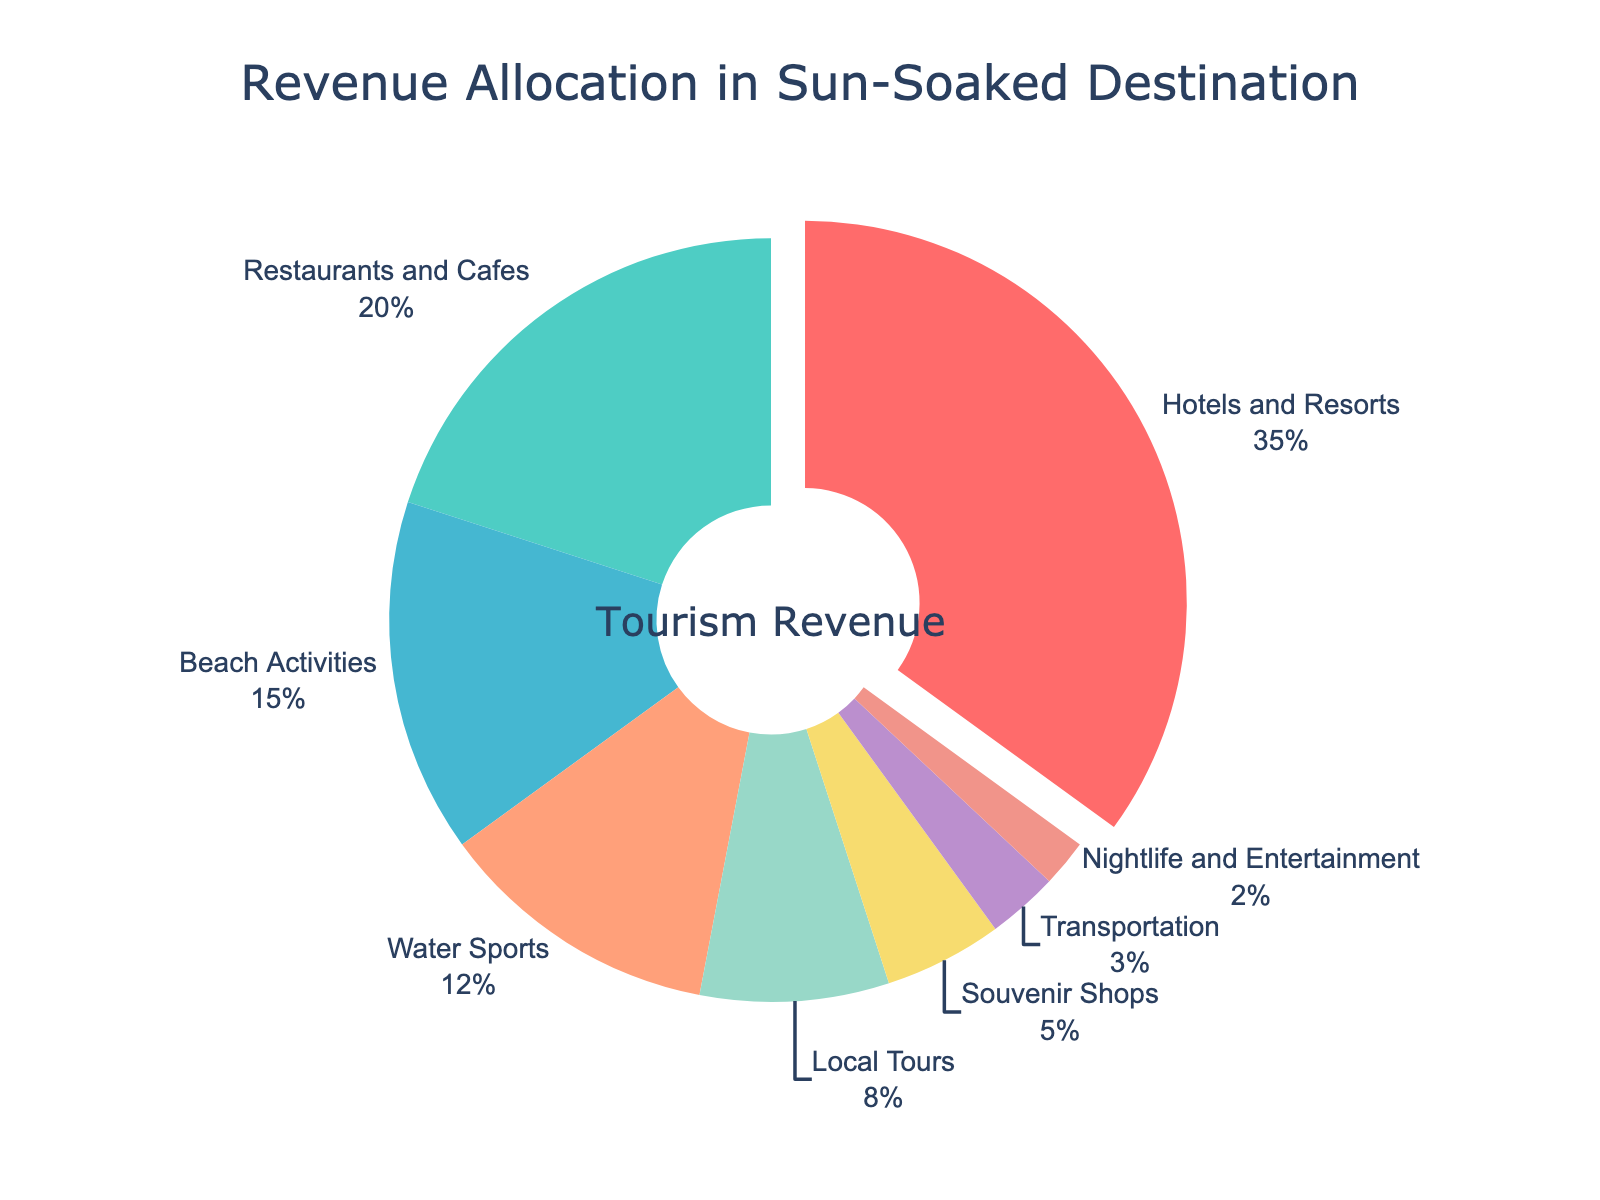What is the title of the plot? The title of the plot is located at the top center of the figure. It reads "Revenue Allocation in Sun-Soaked Destination"
Answer: Revenue Allocation in Sun-Soaked Destination What sector receives the highest revenue percentage? By observing the pie chart, the largest segment corresponds to one of the labels. Here, the largest segment is assigned to "Hotels and Resorts" with 35%.
Answer: Hotels and Resorts What percent of revenue is allocated to Water Sports? Each sector's percentage is labeled directly on the pie chart. The percent value next to Water Sports is 12%.
Answer: 12% Which sector has the smallest share of the revenue? The smallest slice in the pie chart corresponds to "Nightlife and Entertainment" with a 2% share.
Answer: Nightlife and Entertainment What is the combined revenue percentage for Restaurants and Cafes and Beach Activities? Refer to the pie chart percentages: Restaurants and Cafes (20%) + Beach Activities (15%). Sum them up: 20 + 15.
Answer: 35% Is Local Tours allocated more revenue than Souvenir Shops? By comparing the two segments in the pie chart, Local Tours (8%) has a higher percentage than Souvenir Shops (5%).
Answer: Yes How much larger in percentage is Transportation compared to Nightlife and Entertainment? Extract the percentages: Transportation (3%) and Nightlife and Entertainment (2%). Compute the difference: 3% - 2%.
Answer: 1% What sectors combined make up half or more of the total revenue? Summing from the largest portion until exceeding 50%: Hotels and Resorts (35%) + Restaurants and Cafes (20%) = 55%.
Answer: Hotels and Resorts and Restaurants and Cafes Which sectors receive less than 10% of the total revenue? Sectors below 10% are identified by segments labeled <10%: Transportation (3%), Nightlife and Entertainment (2%), Souvenir Shops (5%), Local Tours (8%).
Answer: Transportation, Nightlife and Entertainment, Souvenir Shops, Local Tours What fraction of the total revenue is allocated to Beach Activities versus Water Sports? Extract the percentages for Beach Activities (15%) and Water Sports (12%). The fraction is 15/12, simplified to 5/4.
Answer: 5/4 